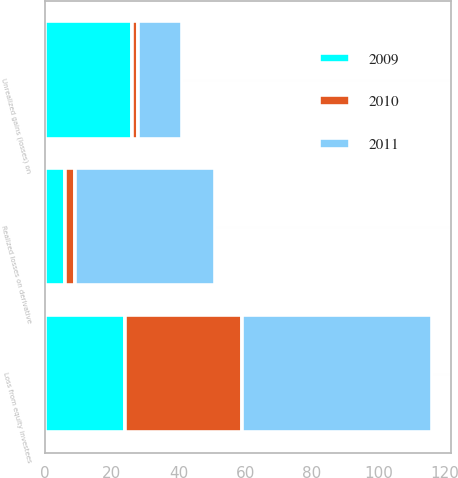Convert chart. <chart><loc_0><loc_0><loc_500><loc_500><stacked_bar_chart><ecel><fcel>Unrealized gains (losses) on<fcel>Realized losses on derivative<fcel>Loss from equity investees<nl><fcel>2010<fcel>2<fcel>3<fcel>35<nl><fcel>2011<fcel>13<fcel>42<fcel>57<nl><fcel>2009<fcel>26<fcel>6<fcel>24<nl></chart> 